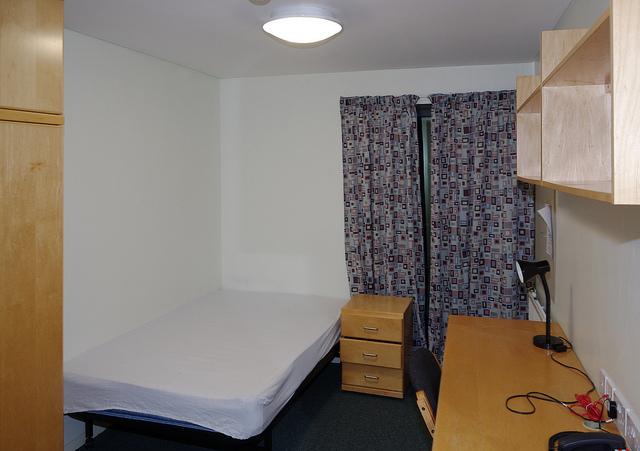Could this room be in a dorm?
Give a very brief answer. Yes. How many dressers?
Be succinct. 1. What is next to the bed?
Keep it brief. Nightstand. 